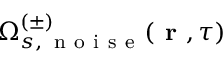Convert formula to latex. <formula><loc_0><loc_0><loc_500><loc_500>\Omega _ { s , \, n o i s e } ^ { ( \pm ) } ( r , \tau )</formula> 